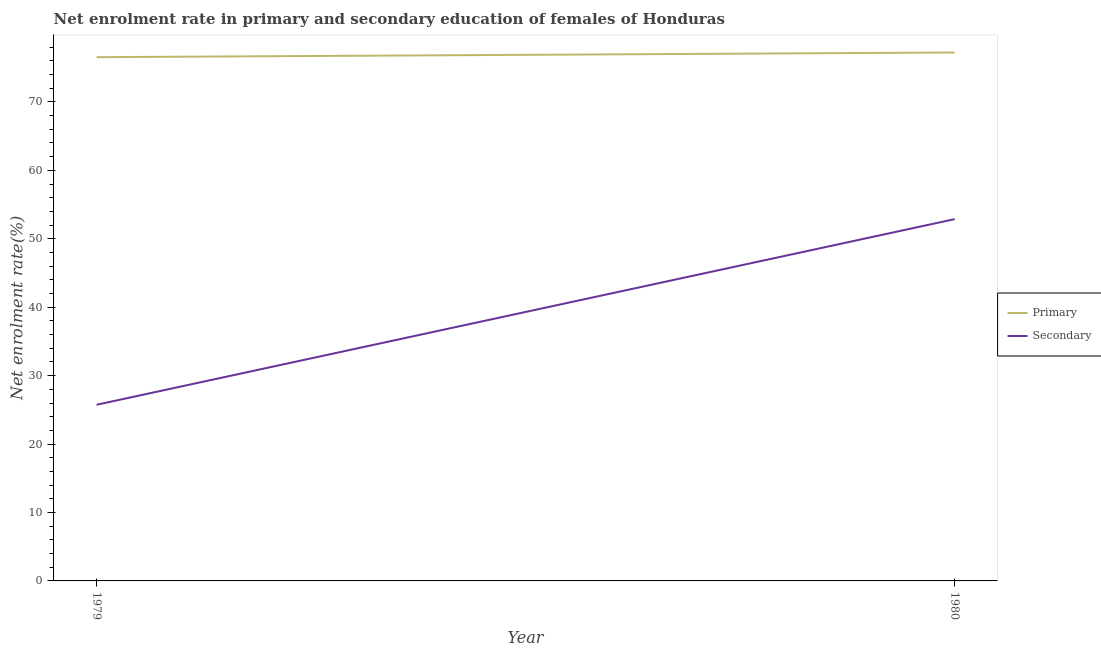Does the line corresponding to enrollment rate in secondary education intersect with the line corresponding to enrollment rate in primary education?
Provide a short and direct response. No. Is the number of lines equal to the number of legend labels?
Make the answer very short. Yes. What is the enrollment rate in primary education in 1979?
Offer a very short reply. 76.54. Across all years, what is the maximum enrollment rate in primary education?
Offer a very short reply. 77.22. Across all years, what is the minimum enrollment rate in primary education?
Make the answer very short. 76.54. In which year was the enrollment rate in primary education maximum?
Your answer should be very brief. 1980. In which year was the enrollment rate in secondary education minimum?
Give a very brief answer. 1979. What is the total enrollment rate in primary education in the graph?
Make the answer very short. 153.76. What is the difference between the enrollment rate in secondary education in 1979 and that in 1980?
Your response must be concise. -27.13. What is the difference between the enrollment rate in secondary education in 1979 and the enrollment rate in primary education in 1980?
Ensure brevity in your answer.  -51.48. What is the average enrollment rate in secondary education per year?
Your response must be concise. 39.31. In the year 1980, what is the difference between the enrollment rate in primary education and enrollment rate in secondary education?
Ensure brevity in your answer.  24.35. In how many years, is the enrollment rate in primary education greater than 30 %?
Offer a very short reply. 2. What is the ratio of the enrollment rate in primary education in 1979 to that in 1980?
Provide a short and direct response. 0.99. Is the enrollment rate in secondary education in 1979 less than that in 1980?
Keep it short and to the point. Yes. Is the enrollment rate in secondary education strictly greater than the enrollment rate in primary education over the years?
Give a very brief answer. No. Is the enrollment rate in secondary education strictly less than the enrollment rate in primary education over the years?
Make the answer very short. Yes. How many lines are there?
Your answer should be very brief. 2. Are the values on the major ticks of Y-axis written in scientific E-notation?
Your answer should be compact. No. How many legend labels are there?
Give a very brief answer. 2. How are the legend labels stacked?
Provide a succinct answer. Vertical. What is the title of the graph?
Give a very brief answer. Net enrolment rate in primary and secondary education of females of Honduras. What is the label or title of the Y-axis?
Provide a short and direct response. Net enrolment rate(%). What is the Net enrolment rate(%) in Primary in 1979?
Provide a succinct answer. 76.54. What is the Net enrolment rate(%) of Secondary in 1979?
Your answer should be compact. 25.74. What is the Net enrolment rate(%) of Primary in 1980?
Keep it short and to the point. 77.22. What is the Net enrolment rate(%) in Secondary in 1980?
Your answer should be very brief. 52.87. Across all years, what is the maximum Net enrolment rate(%) in Primary?
Your response must be concise. 77.22. Across all years, what is the maximum Net enrolment rate(%) in Secondary?
Your answer should be compact. 52.87. Across all years, what is the minimum Net enrolment rate(%) of Primary?
Offer a terse response. 76.54. Across all years, what is the minimum Net enrolment rate(%) of Secondary?
Provide a succinct answer. 25.74. What is the total Net enrolment rate(%) in Primary in the graph?
Your response must be concise. 153.76. What is the total Net enrolment rate(%) of Secondary in the graph?
Offer a very short reply. 78.61. What is the difference between the Net enrolment rate(%) in Primary in 1979 and that in 1980?
Your answer should be compact. -0.68. What is the difference between the Net enrolment rate(%) in Secondary in 1979 and that in 1980?
Make the answer very short. -27.13. What is the difference between the Net enrolment rate(%) of Primary in 1979 and the Net enrolment rate(%) of Secondary in 1980?
Give a very brief answer. 23.67. What is the average Net enrolment rate(%) of Primary per year?
Keep it short and to the point. 76.88. What is the average Net enrolment rate(%) in Secondary per year?
Make the answer very short. 39.31. In the year 1979, what is the difference between the Net enrolment rate(%) of Primary and Net enrolment rate(%) of Secondary?
Your answer should be very brief. 50.8. In the year 1980, what is the difference between the Net enrolment rate(%) of Primary and Net enrolment rate(%) of Secondary?
Your answer should be compact. 24.35. What is the ratio of the Net enrolment rate(%) of Secondary in 1979 to that in 1980?
Offer a very short reply. 0.49. What is the difference between the highest and the second highest Net enrolment rate(%) in Primary?
Keep it short and to the point. 0.68. What is the difference between the highest and the second highest Net enrolment rate(%) of Secondary?
Make the answer very short. 27.13. What is the difference between the highest and the lowest Net enrolment rate(%) of Primary?
Provide a short and direct response. 0.68. What is the difference between the highest and the lowest Net enrolment rate(%) of Secondary?
Ensure brevity in your answer.  27.13. 